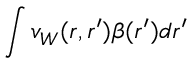Convert formula to latex. <formula><loc_0><loc_0><loc_500><loc_500>\int v _ { W } ( r , r ^ { \prime } ) \beta ( r ^ { \prime } ) d r ^ { \prime }</formula> 